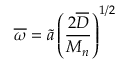<formula> <loc_0><loc_0><loc_500><loc_500>\overline { \omega } = \tilde { a } \left ( \frac { 2 \overline { D } } { M _ { n } } \right ) ^ { 1 / 2 }</formula> 